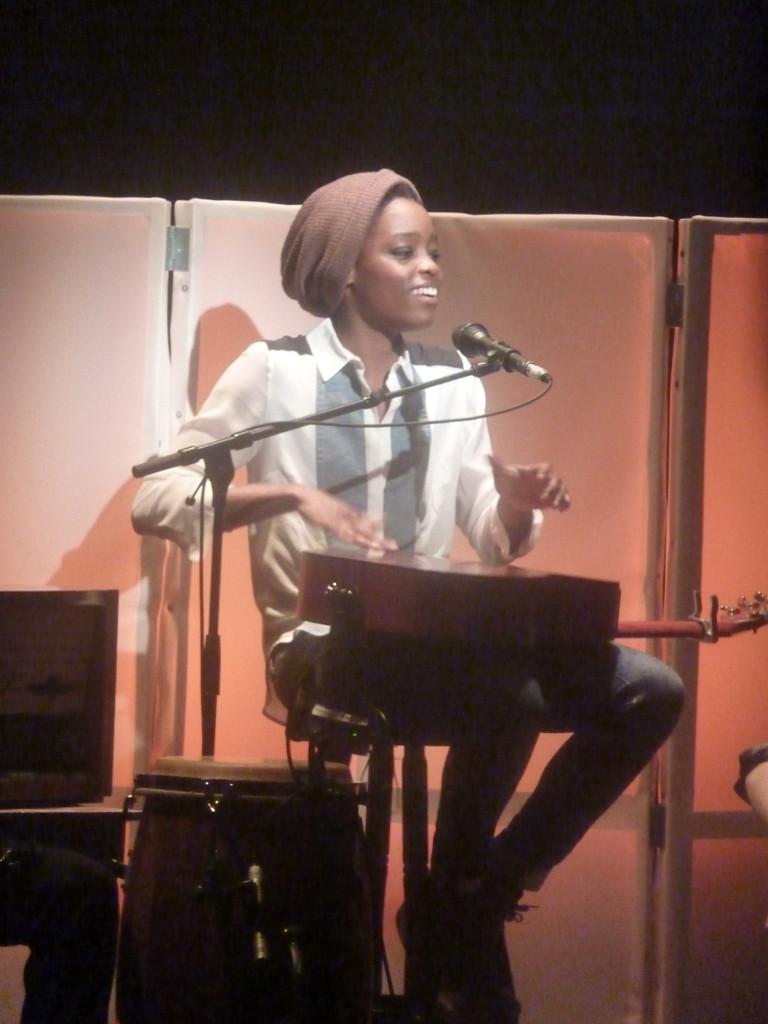In one or two sentences, can you explain what this image depicts? The picture consists of a lady singing on mic and tapping on guitar. 